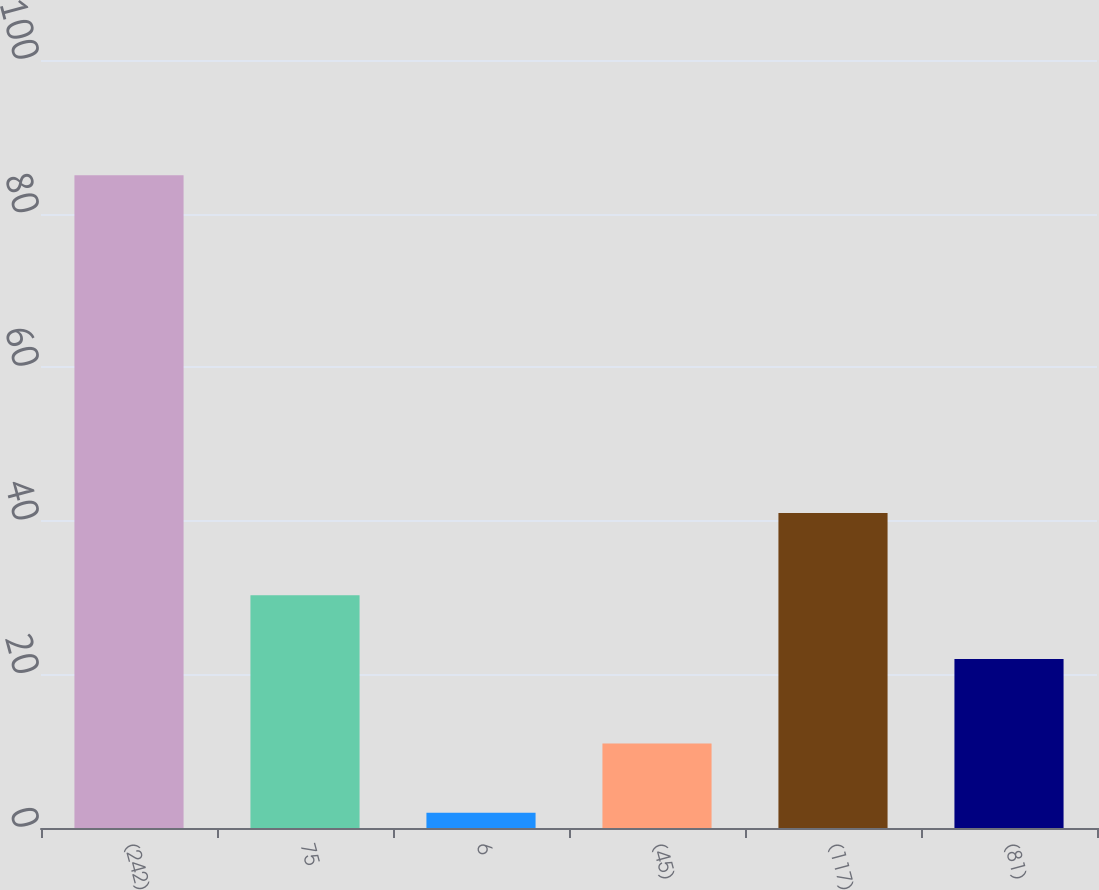Convert chart. <chart><loc_0><loc_0><loc_500><loc_500><bar_chart><fcel>(242)<fcel>75<fcel>6<fcel>(45)<fcel>(117)<fcel>(81)<nl><fcel>85<fcel>30.3<fcel>2<fcel>11<fcel>41<fcel>22<nl></chart> 